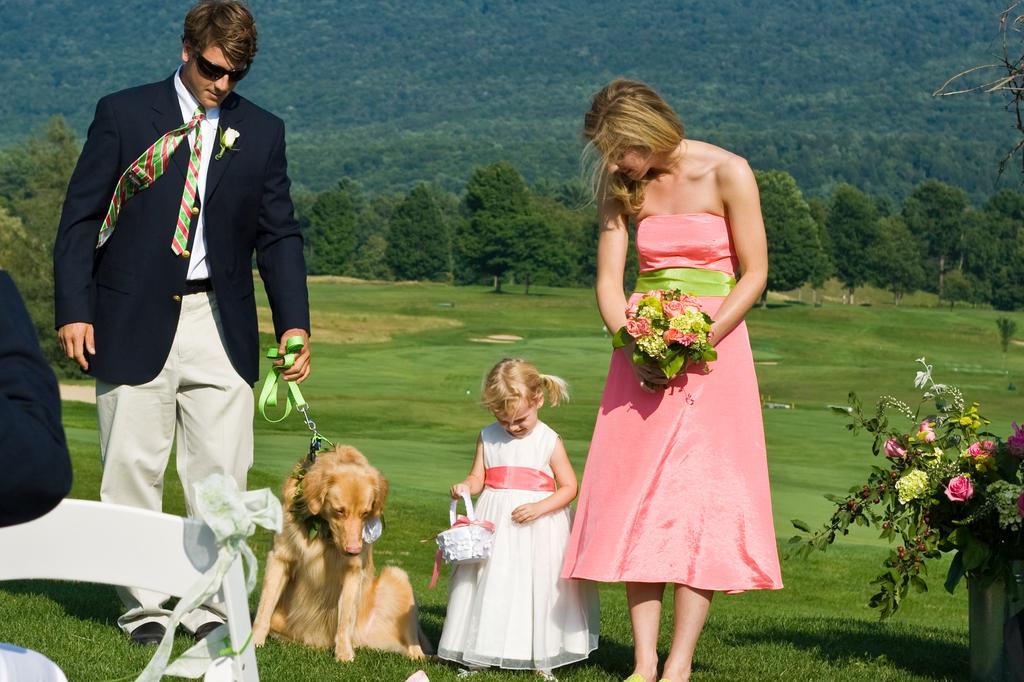Could you give a brief overview of what you see in this image? In this image we can see a person who is on the left side and he is holding a dog. Here we can see a woman standing on the right side and she is holding a flowers in her hand and there is a baby girl in the center and she is holding a basket. In background we can see trees. 